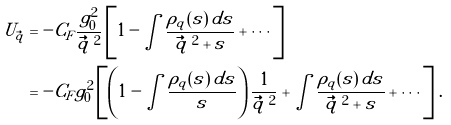<formula> <loc_0><loc_0><loc_500><loc_500>U _ { \vec { q } } & = - C _ { F } \frac { g _ { 0 } ^ { 2 } } { \vec { q } \, ^ { 2 } } \left [ 1 - \int \frac { \rho _ { q } ( s ) \, d s } { \vec { q } \, ^ { 2 } + s } + \cdots \right ] \\ & = - C _ { F } g _ { 0 } ^ { 2 } \left [ \left ( 1 - \int \frac { \rho _ { q } ( s ) \, d s } { s } \right ) \frac { 1 } { \vec { q } \, ^ { 2 } } + \int \frac { \rho _ { q } ( s ) \, d s } { \vec { q } \, ^ { 2 } + s } + \cdots \right ] \, .</formula> 